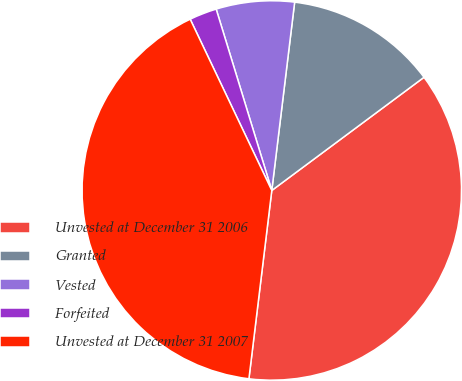<chart> <loc_0><loc_0><loc_500><loc_500><pie_chart><fcel>Unvested at December 31 2006<fcel>Granted<fcel>Vested<fcel>Forfeited<fcel>Unvested at December 31 2007<nl><fcel>37.1%<fcel>12.9%<fcel>6.66%<fcel>2.34%<fcel>41.0%<nl></chart> 